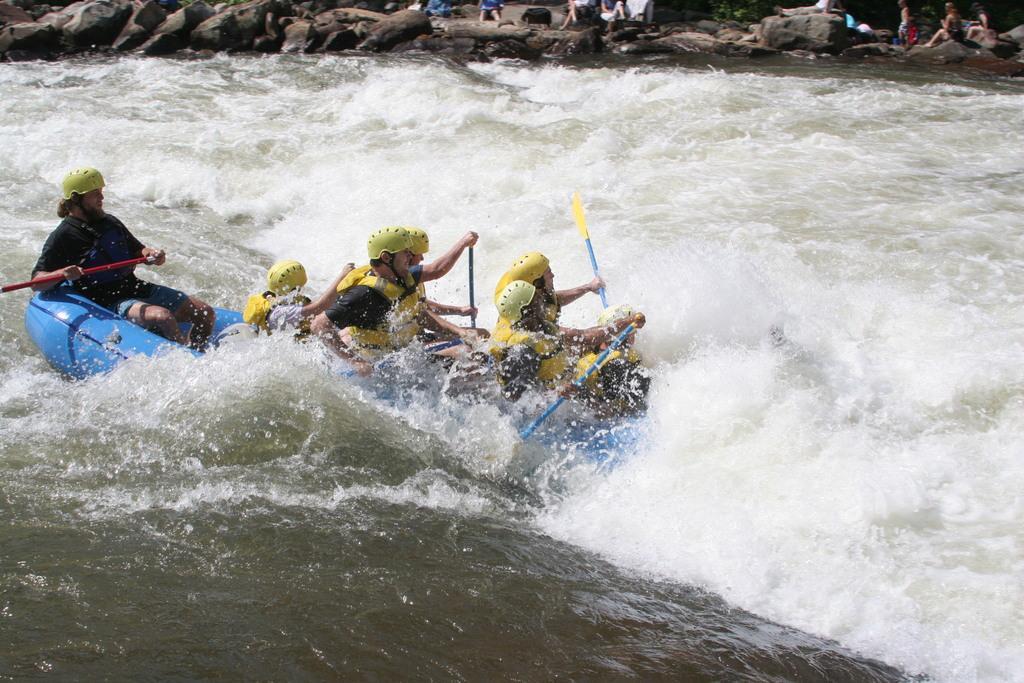Can you describe this image briefly? In this image we can see a few people, among them some people are rowing, there are some rocks and trees. 